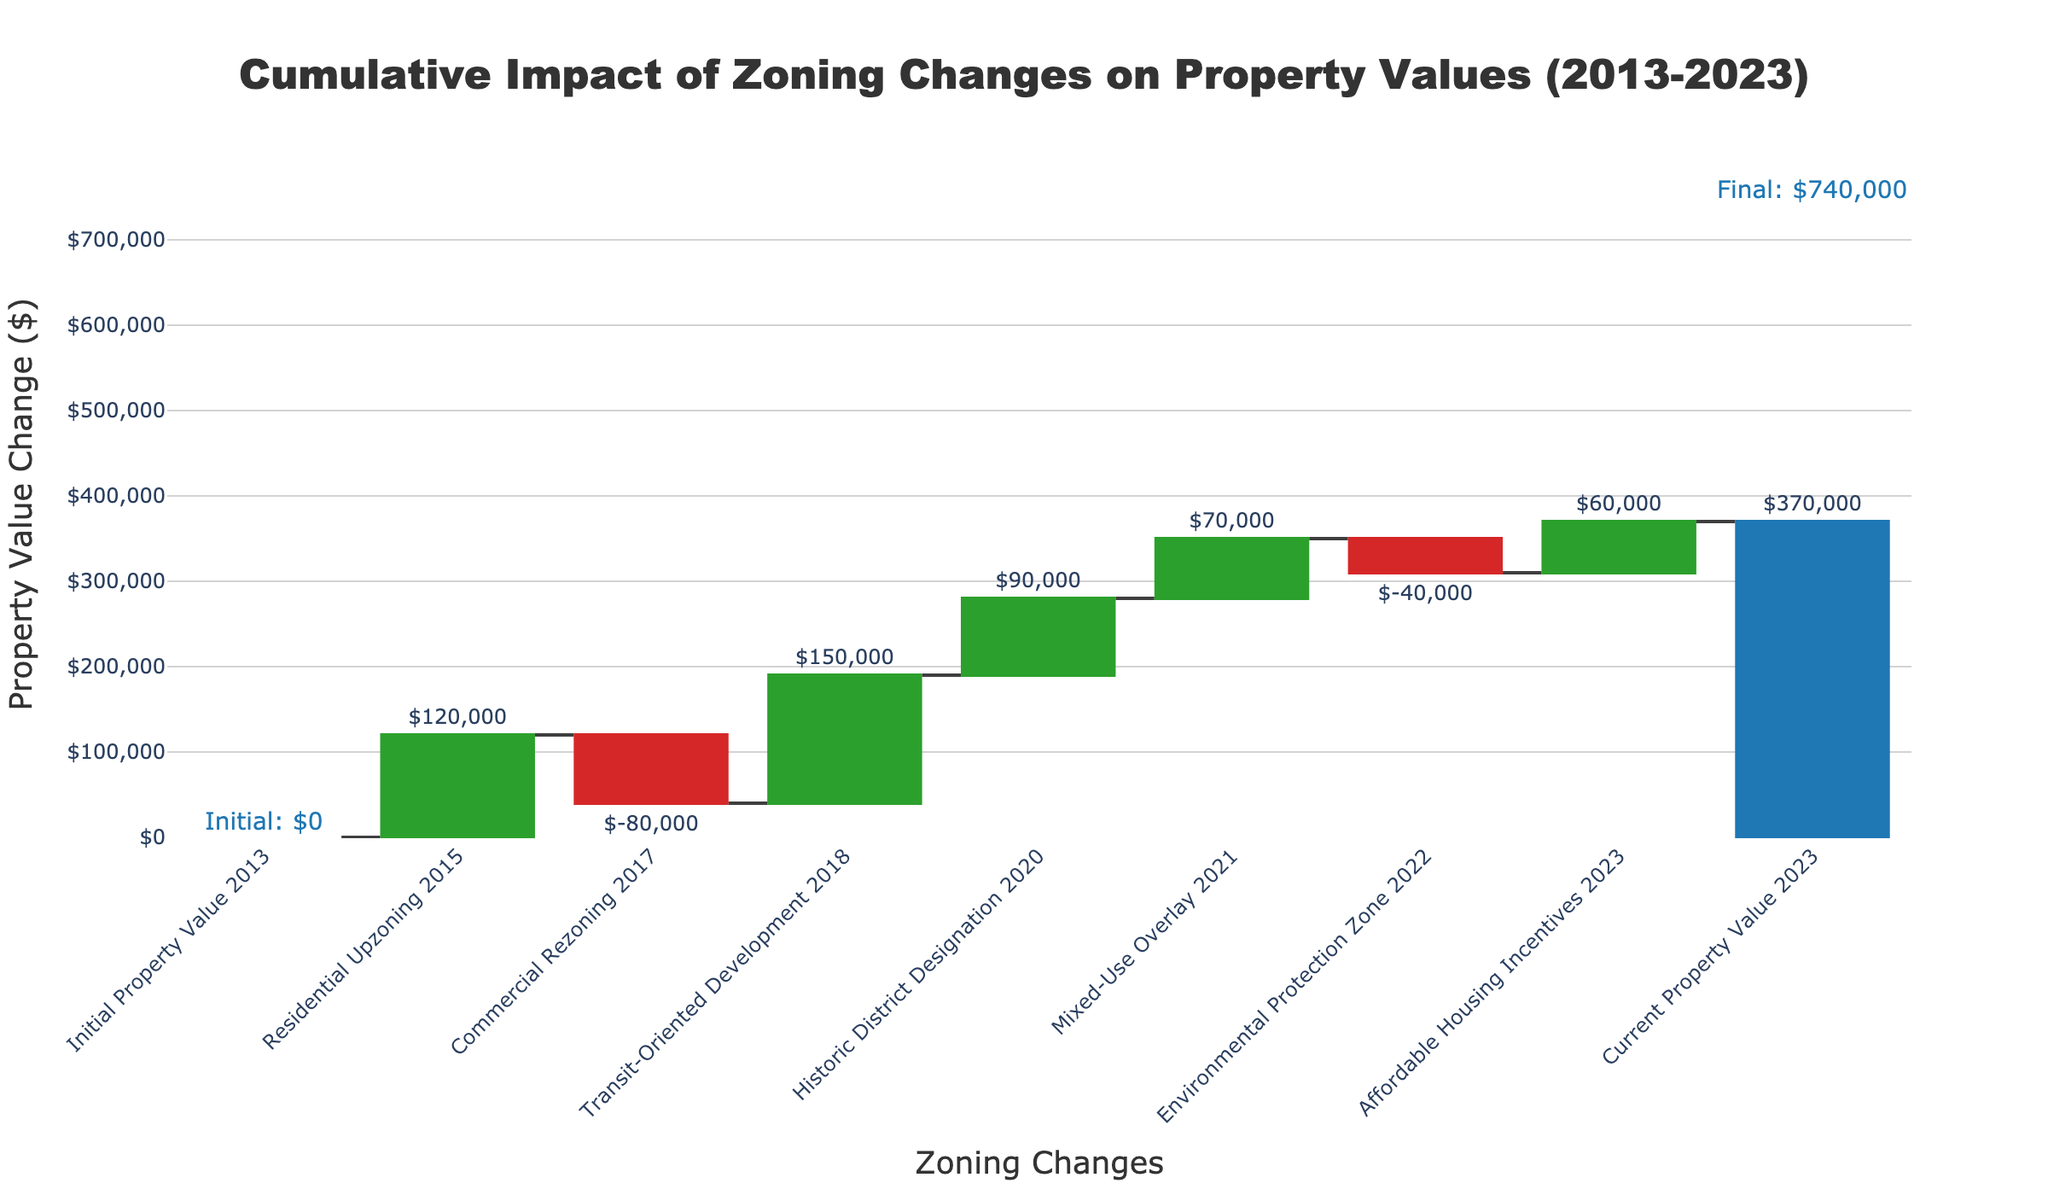What is the title of the waterfall chart? The title of the chart is typically displayed prominently at the top of the figure. It serves to describe the primary focus of the entire chart. In this example, the title is positioned at the top center of the figure, clearly stating the subject.
Answer: Cumulative Impact of Zoning Changes on Property Values (2013-2023) What is the initial property value in 2013? To find the initial property value in 2013, look at the first bar labeled "Initial Property Value 2013." The top of this bar aligns with a text annotation.
Answer: $0 Which zoning change increased property values the most? Examine the height of the bars, focusing on the ones that increase in height (green bars). The tallest increasing bar indicates the largest positive change.
Answer: Transit-Oriented Development 2018 What is the total cumulative impact on property values by 2023? The total cumulative impact is shown by the final bar in the chart, which aggregates all previous changes. This bar is typically a different color to indicate it's a total.
Answer: $370,000 Which year saw the largest decrease in property values? To identify the largest decrease, look for the tallest decreasing bar (red bar) in the chart and note the year associated with it.
Answer: Commercial Rezoning 2017 What is the net impact of zoning changes from Historic District Designation 2020 and Mixed-Use Overlay 2021 combined? Look at the labels for the bars for "Historic District Designation" and "Mixed-Use Overlay." Sum the values for these two categories.
Answer: $90,000 + $70,000 = $160,000 How many zoning changes resulted in a decrease in property values? Count the number of red bars in the waterfall chart, as they visually represent decreases in value.
Answer: 2 Which zoning change had a smaller positive impact on property values: Residential Upzoning 2015 or Affordable Housing Incentives 2023? Compare the heights or labeled values of the bars for "Residential Upzoning 2015" and "Affordable Housing Incentives 2023".
Answer: Residential Upzoning 2015 By how much did the Commercial Rezoning 2017 reduce property values? Find the labeled value of the bar for "Commercial Rezoning 2017." The reduction in value is shown directly on the bar.
Answer: $80,000 What is the cumulative increase in property values by the end of 2018? Summing the values of the bars from 2015 to 2018 (inclusive) provides the cumulative increase by the end of 2018.
Answer: $120,000 - $80,000 + $150,000 = $190,000 